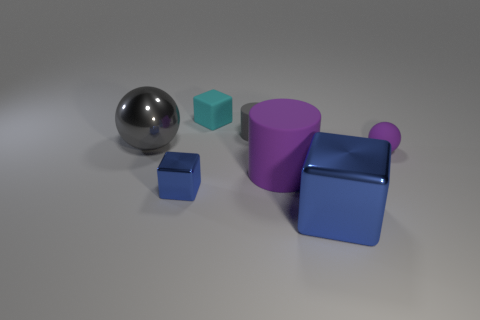If these objects were part of a child's toy set, what kind of game could you imagine being played with them? These objects could be part of an educational toy set designed to teach children about shapes and colors. A possible game could involve matching each object with corresponding silhouettes on a game board, or stacking them based on size, encouraging spatial awareness and motor skills development. 